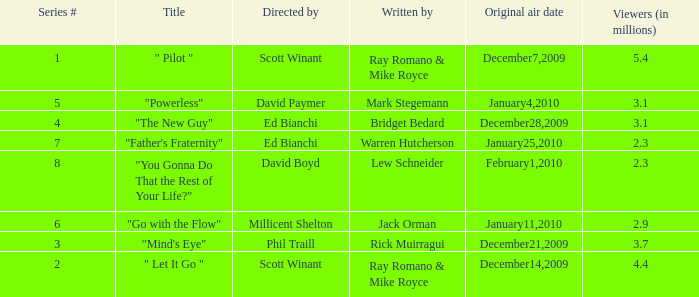When did the episode  "you gonna do that the rest of your life?" air? February1,2010. 